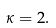Convert formula to latex. <formula><loc_0><loc_0><loc_500><loc_500>\kappa = 2 .</formula> 